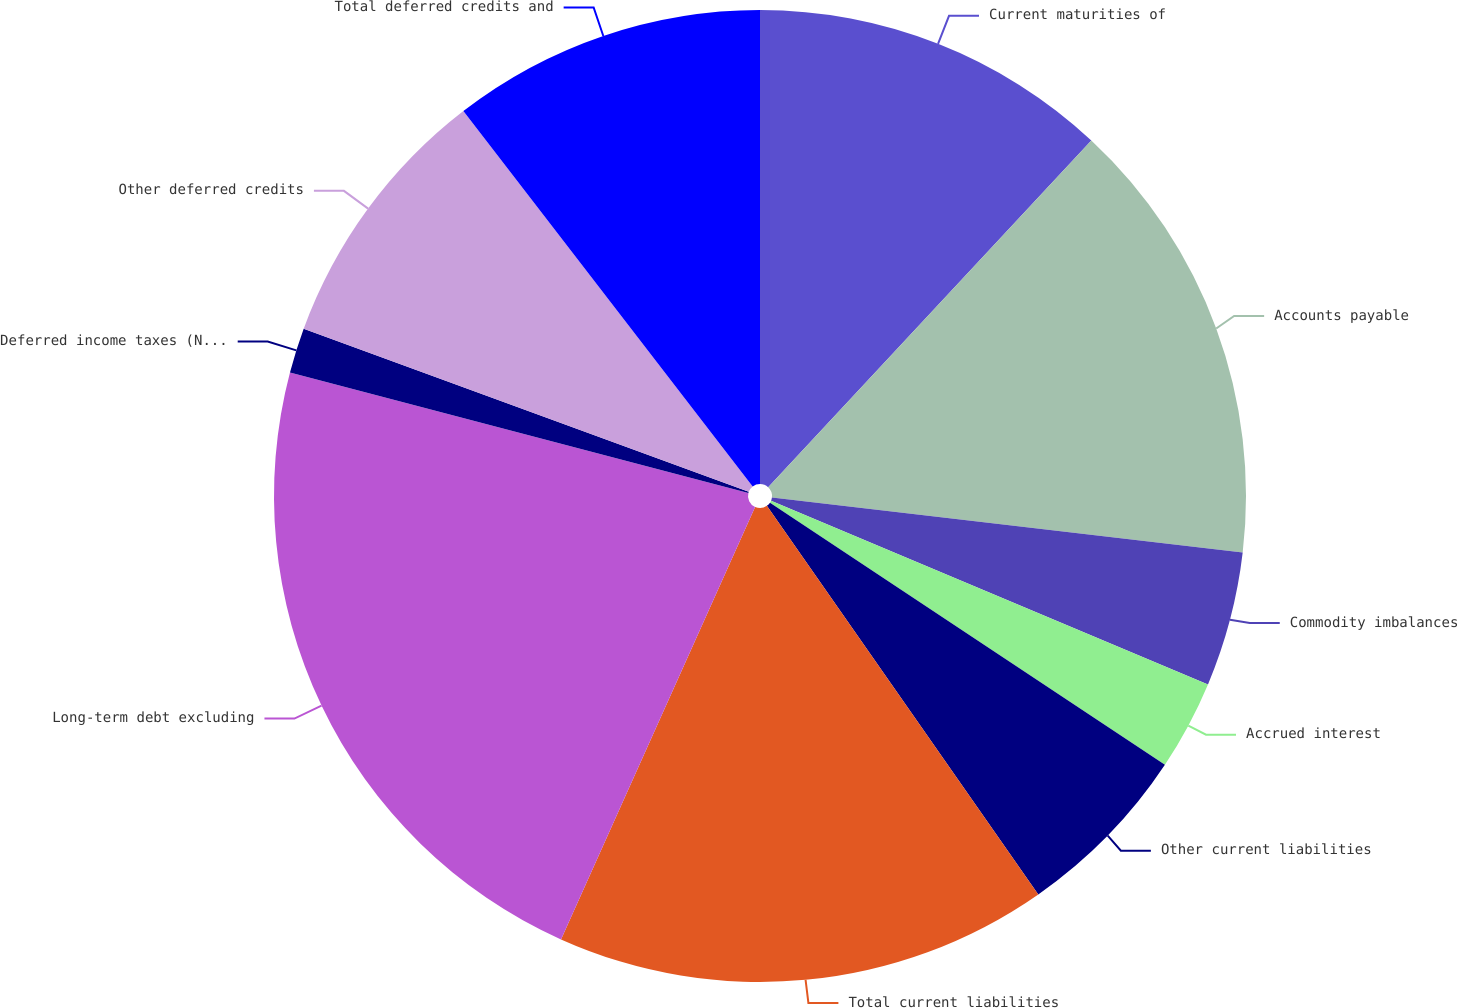Convert chart to OTSL. <chart><loc_0><loc_0><loc_500><loc_500><pie_chart><fcel>Current maturities of<fcel>Accounts payable<fcel>Commodity imbalances<fcel>Accrued interest<fcel>Other current liabilities<fcel>Total current liabilities<fcel>Long-term debt excluding<fcel>Deferred income taxes (Note L)<fcel>Other deferred credits<fcel>Total deferred credits and<nl><fcel>11.94%<fcel>14.92%<fcel>4.48%<fcel>2.99%<fcel>5.97%<fcel>16.42%<fcel>22.38%<fcel>1.5%<fcel>8.96%<fcel>10.45%<nl></chart> 